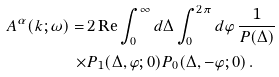<formula> <loc_0><loc_0><loc_500><loc_500>A ^ { \alpha } ( k ; \omega ) = \, & 2 \, \text {Re} \int _ { 0 } ^ { \infty } d \Delta \int _ { 0 } ^ { 2 \pi } d \varphi \, \frac { 1 } { P ( \Delta ) } \\ \times & P _ { 1 } ( \Delta , \varphi ; 0 ) P _ { 0 } ( \Delta , - \varphi ; 0 ) \, .</formula> 